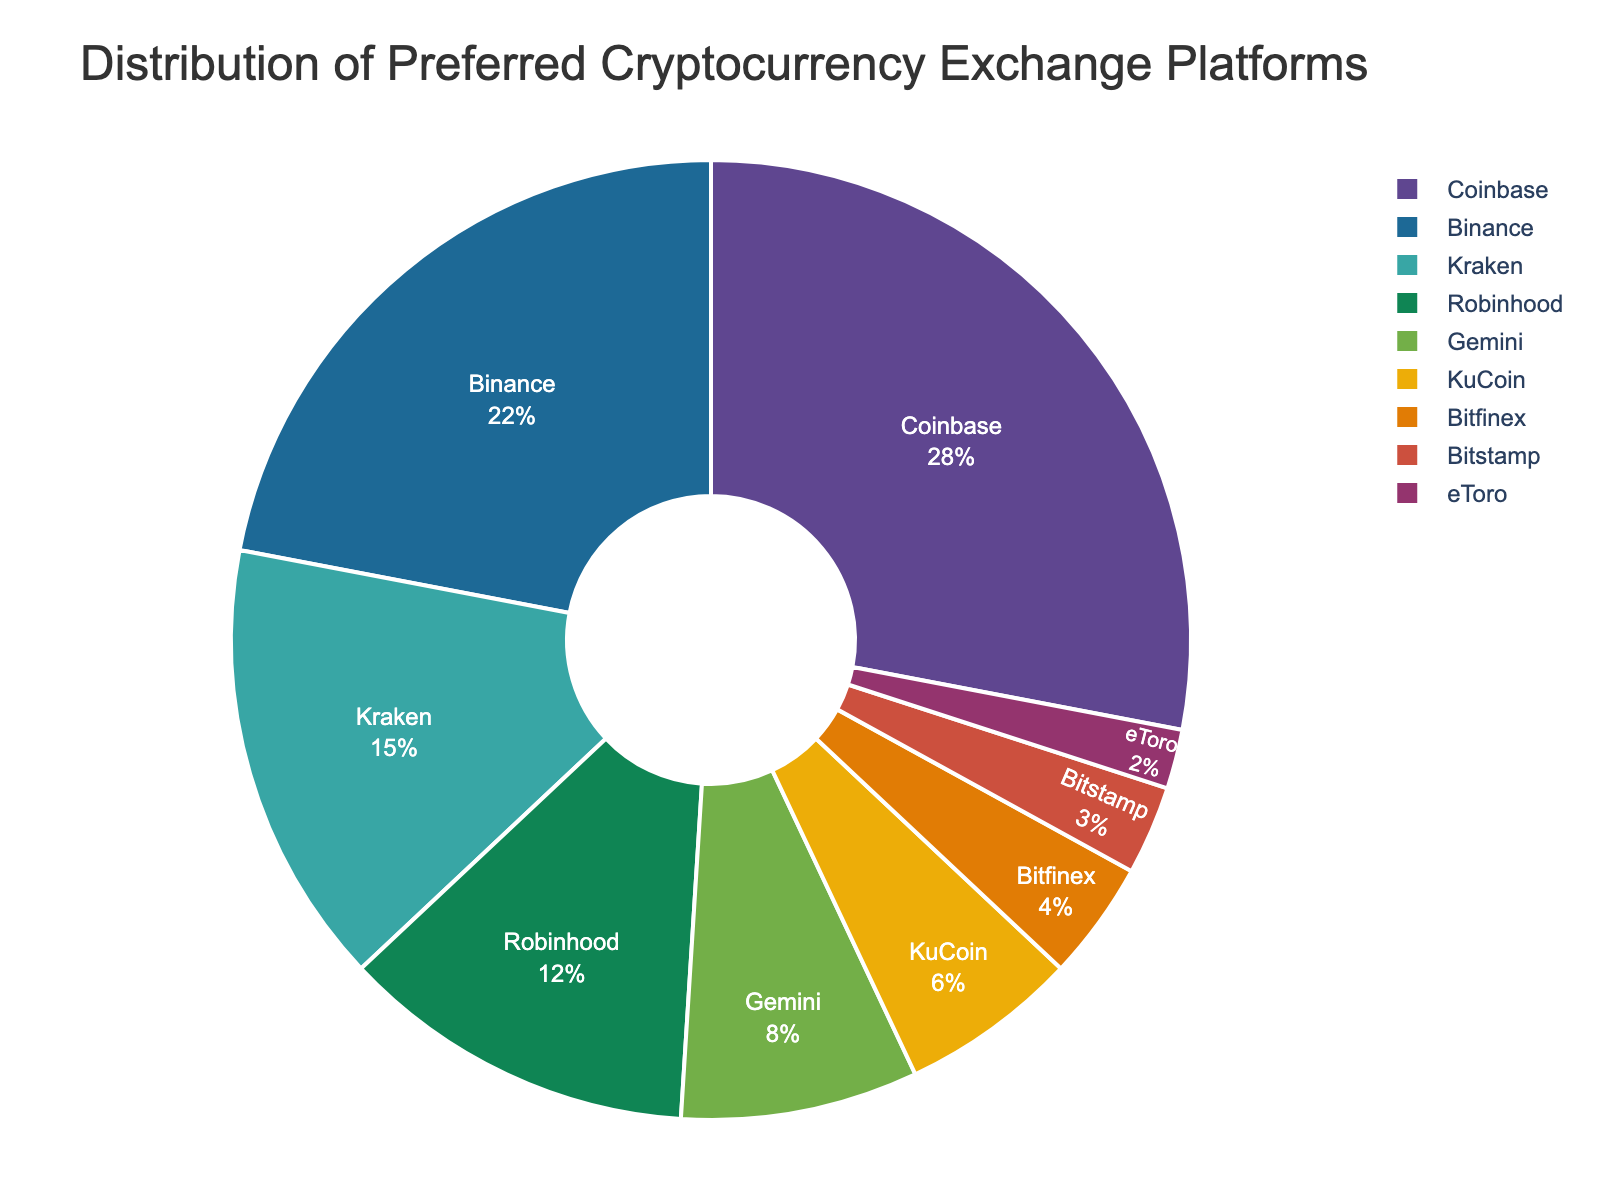What is the most preferred cryptocurrency exchange platform among college-age investors? The pie chart shows the different cryptocurrency exchange platforms and their respective percentages. The platform with the largest percentage is the most preferred.
Answer: Coinbase Which platform is less preferred: Kraken or Robinhood? The pie chart displays the percentages for each platform. Kraken has 15% while Robinhood has 12%.
Answer: Robinhood What is the combined percentage of users for Coinbase and Binance? Sum the percentages of Coinbase (28%) and Binance (22%). 28% + 22% = 50%.
Answer: 50% How much more popular is Coinbase compared to Bitstamp? Subtract the percentage of Bitstamp (3%) from Coinbase (28%). 28% - 3% = 25%.
Answer: 25% Which three platforms have the smallest market share? Identify the platforms with the smallest percentages in the pie chart. They are eToro, Bitstamp, and Bitfinex with 2%, 3%, and 4% respectively.
Answer: eToro, Bitstamp, Bitfinex How many platforms have a market share greater than 10%? Count the platforms in the pie chart with percentages greater than 10%. They are Coinbase (28%), Binance (22%), Kraken (15%), and Robinhood (12%).
Answer: 4 By how much does Gemini exceed KuCoin in terms of percentage? Subtract the percentage of KuCoin (6%) from Gemini (8%). 8% - 6% = 2%.
Answer: 2% What platform holds an 8% market share and what color represents it in the pie chart? Identify the platform with an 8% share from the chart. Gemini holds 8%. The color representation can be identified visually (specific color depends on the rendering of the chart).
Answer: Gemini (Color depends on chart) Which platforms together make up exactly 20% of the market share? Sum the percentages of platforms to identify which combination equals 20%. KuCoin (6%) + Bitfinex (4%) + Bitstamp (3%) + eToro (2%) = 15%, not enough. Kraken (15%) + Bitfinex (4%) + Bitstamp (3%) = still not working. Robinhood (12%) + Gemini (8%) = the combination that makes 20%.
Answer: Robinhood and Gemini Based on the pie chart, which two platforms combined have a higher share than Binance? Binance has 22%. Kraken (15%) + Robinhood (12%) = 27%, which is higher.
Answer: Kraken and Robinhood 